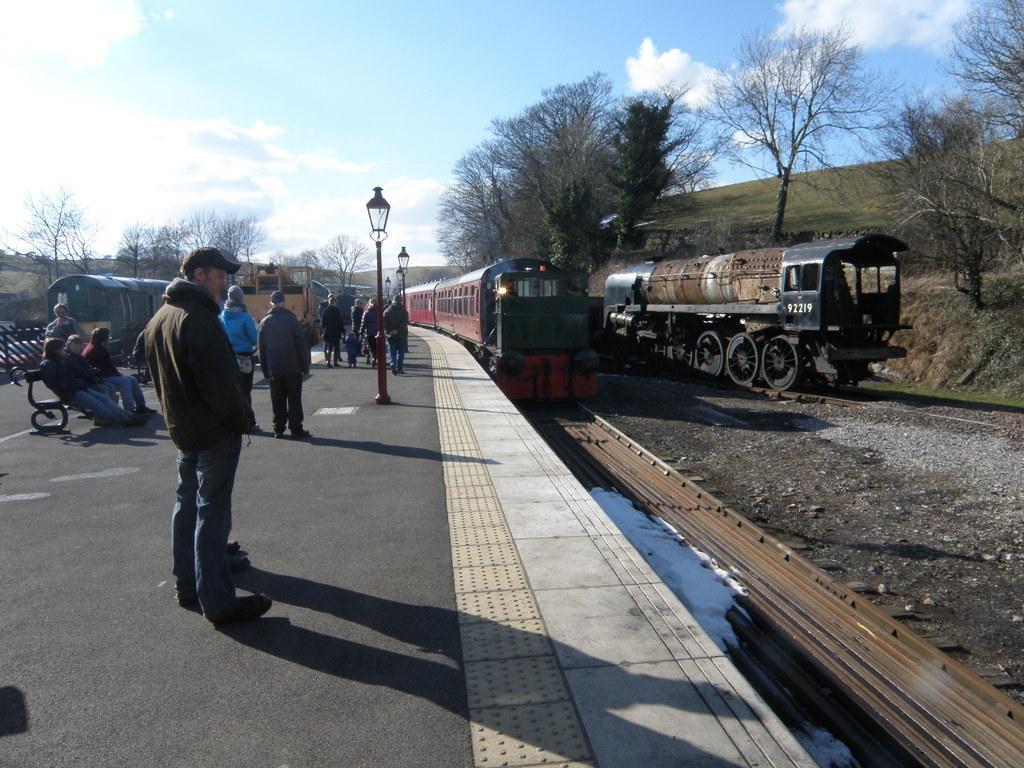Could you give a brief overview of what you see in this image? In the center of the image there is a train on the railway track. On the right side of the image we can see train, trees, hill. On the left side of the image we can see persons on the road, street lights and trees. In the background we can see sky and clouds. 